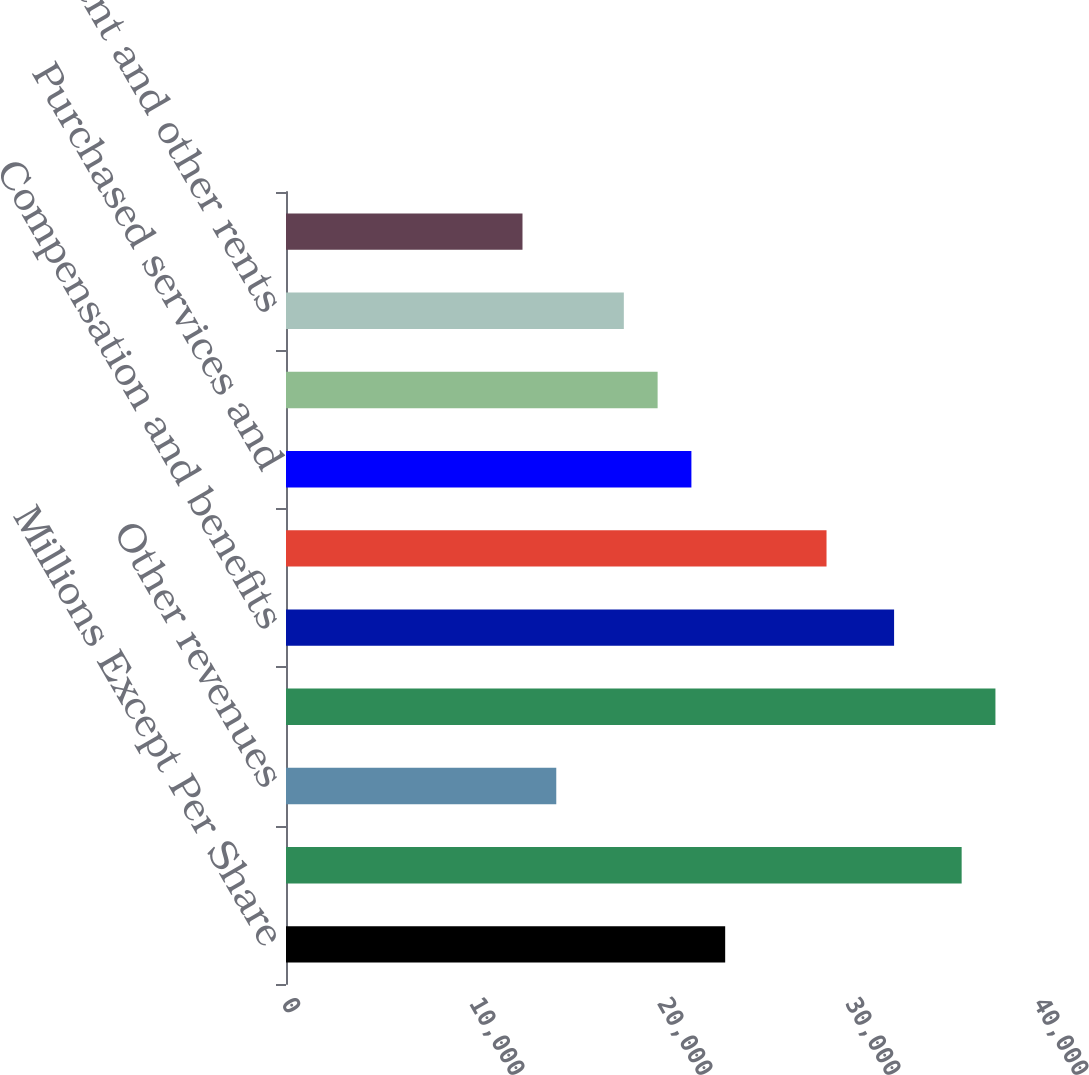Convert chart. <chart><loc_0><loc_0><loc_500><loc_500><bar_chart><fcel>Millions Except Per Share<fcel>Freight revenues<fcel>Other revenues<fcel>Total operating revenues<fcel>Compensation and benefits<fcel>Fuel<fcel>Purchased services and<fcel>Depreciation<fcel>Equipment and other rents<fcel>Other<nl><fcel>23360.7<fcel>35939<fcel>14376.2<fcel>37735.9<fcel>32345.2<fcel>28751.4<fcel>21563.8<fcel>19766.9<fcel>17970<fcel>12579.3<nl></chart> 